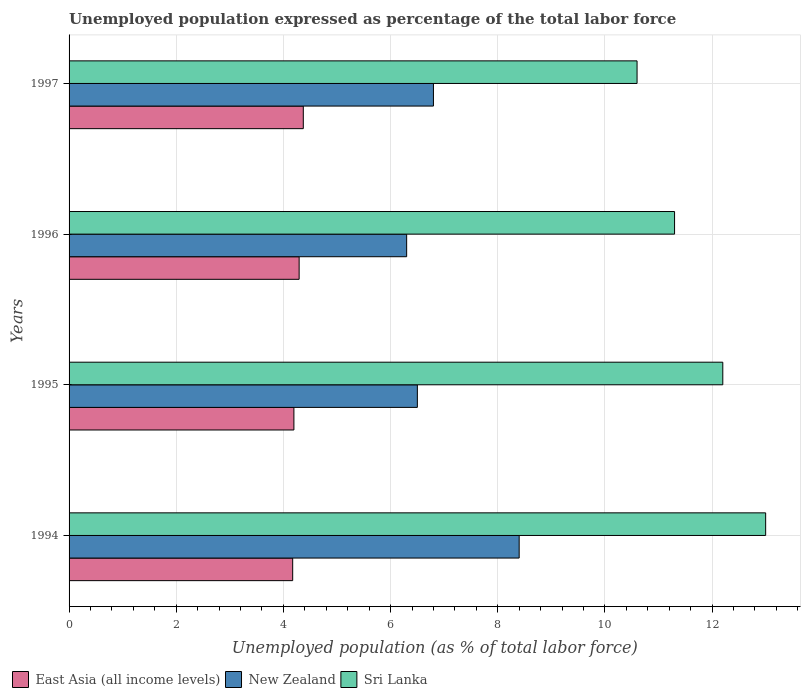How many bars are there on the 1st tick from the top?
Provide a short and direct response. 3. How many bars are there on the 4th tick from the bottom?
Your answer should be compact. 3. What is the label of the 4th group of bars from the top?
Provide a short and direct response. 1994. In how many cases, is the number of bars for a given year not equal to the number of legend labels?
Provide a short and direct response. 0. What is the unemployment in in East Asia (all income levels) in 1997?
Give a very brief answer. 4.37. Across all years, what is the maximum unemployment in in New Zealand?
Your answer should be compact. 8.4. Across all years, what is the minimum unemployment in in Sri Lanka?
Offer a very short reply. 10.6. In which year was the unemployment in in Sri Lanka maximum?
Provide a succinct answer. 1994. In which year was the unemployment in in Sri Lanka minimum?
Keep it short and to the point. 1997. What is the total unemployment in in Sri Lanka in the graph?
Make the answer very short. 47.1. What is the difference between the unemployment in in Sri Lanka in 1995 and that in 1997?
Offer a very short reply. 1.6. What is the difference between the unemployment in in New Zealand in 1994 and the unemployment in in Sri Lanka in 1996?
Give a very brief answer. -2.9. What is the average unemployment in in New Zealand per year?
Ensure brevity in your answer.  7. In the year 1996, what is the difference between the unemployment in in Sri Lanka and unemployment in in New Zealand?
Your answer should be very brief. 5. What is the ratio of the unemployment in in East Asia (all income levels) in 1995 to that in 1996?
Provide a short and direct response. 0.98. What is the difference between the highest and the second highest unemployment in in East Asia (all income levels)?
Offer a very short reply. 0.08. What is the difference between the highest and the lowest unemployment in in New Zealand?
Your answer should be compact. 2.1. Is the sum of the unemployment in in Sri Lanka in 1994 and 1996 greater than the maximum unemployment in in New Zealand across all years?
Make the answer very short. Yes. What does the 1st bar from the top in 1996 represents?
Offer a very short reply. Sri Lanka. What does the 1st bar from the bottom in 1996 represents?
Provide a succinct answer. East Asia (all income levels). Are all the bars in the graph horizontal?
Offer a very short reply. Yes. How many years are there in the graph?
Your answer should be compact. 4. What is the difference between two consecutive major ticks on the X-axis?
Provide a short and direct response. 2. Are the values on the major ticks of X-axis written in scientific E-notation?
Make the answer very short. No. How are the legend labels stacked?
Offer a terse response. Horizontal. What is the title of the graph?
Make the answer very short. Unemployed population expressed as percentage of the total labor force. Does "Bolivia" appear as one of the legend labels in the graph?
Offer a very short reply. No. What is the label or title of the X-axis?
Your answer should be very brief. Unemployed population (as % of total labor force). What is the label or title of the Y-axis?
Offer a terse response. Years. What is the Unemployed population (as % of total labor force) of East Asia (all income levels) in 1994?
Keep it short and to the point. 4.17. What is the Unemployed population (as % of total labor force) of New Zealand in 1994?
Provide a succinct answer. 8.4. What is the Unemployed population (as % of total labor force) of Sri Lanka in 1994?
Your answer should be very brief. 13. What is the Unemployed population (as % of total labor force) in East Asia (all income levels) in 1995?
Provide a short and direct response. 4.2. What is the Unemployed population (as % of total labor force) in New Zealand in 1995?
Make the answer very short. 6.5. What is the Unemployed population (as % of total labor force) in Sri Lanka in 1995?
Provide a short and direct response. 12.2. What is the Unemployed population (as % of total labor force) in East Asia (all income levels) in 1996?
Provide a short and direct response. 4.29. What is the Unemployed population (as % of total labor force) in New Zealand in 1996?
Your answer should be very brief. 6.3. What is the Unemployed population (as % of total labor force) in Sri Lanka in 1996?
Your answer should be compact. 11.3. What is the Unemployed population (as % of total labor force) of East Asia (all income levels) in 1997?
Your answer should be compact. 4.37. What is the Unemployed population (as % of total labor force) of New Zealand in 1997?
Make the answer very short. 6.8. What is the Unemployed population (as % of total labor force) in Sri Lanka in 1997?
Your response must be concise. 10.6. Across all years, what is the maximum Unemployed population (as % of total labor force) of East Asia (all income levels)?
Offer a very short reply. 4.37. Across all years, what is the maximum Unemployed population (as % of total labor force) in New Zealand?
Your answer should be very brief. 8.4. Across all years, what is the minimum Unemployed population (as % of total labor force) of East Asia (all income levels)?
Make the answer very short. 4.17. Across all years, what is the minimum Unemployed population (as % of total labor force) of New Zealand?
Offer a terse response. 6.3. Across all years, what is the minimum Unemployed population (as % of total labor force) in Sri Lanka?
Offer a very short reply. 10.6. What is the total Unemployed population (as % of total labor force) in East Asia (all income levels) in the graph?
Your response must be concise. 17.03. What is the total Unemployed population (as % of total labor force) in Sri Lanka in the graph?
Provide a short and direct response. 47.1. What is the difference between the Unemployed population (as % of total labor force) of East Asia (all income levels) in 1994 and that in 1995?
Offer a terse response. -0.02. What is the difference between the Unemployed population (as % of total labor force) of Sri Lanka in 1994 and that in 1995?
Give a very brief answer. 0.8. What is the difference between the Unemployed population (as % of total labor force) of East Asia (all income levels) in 1994 and that in 1996?
Offer a terse response. -0.12. What is the difference between the Unemployed population (as % of total labor force) in New Zealand in 1994 and that in 1996?
Ensure brevity in your answer.  2.1. What is the difference between the Unemployed population (as % of total labor force) of Sri Lanka in 1994 and that in 1996?
Provide a succinct answer. 1.7. What is the difference between the Unemployed population (as % of total labor force) in East Asia (all income levels) in 1994 and that in 1997?
Make the answer very short. -0.2. What is the difference between the Unemployed population (as % of total labor force) of Sri Lanka in 1994 and that in 1997?
Keep it short and to the point. 2.4. What is the difference between the Unemployed population (as % of total labor force) of East Asia (all income levels) in 1995 and that in 1996?
Provide a short and direct response. -0.1. What is the difference between the Unemployed population (as % of total labor force) of Sri Lanka in 1995 and that in 1996?
Your response must be concise. 0.9. What is the difference between the Unemployed population (as % of total labor force) of East Asia (all income levels) in 1995 and that in 1997?
Offer a terse response. -0.18. What is the difference between the Unemployed population (as % of total labor force) of East Asia (all income levels) in 1996 and that in 1997?
Your response must be concise. -0.08. What is the difference between the Unemployed population (as % of total labor force) in New Zealand in 1996 and that in 1997?
Provide a short and direct response. -0.5. What is the difference between the Unemployed population (as % of total labor force) of Sri Lanka in 1996 and that in 1997?
Your response must be concise. 0.7. What is the difference between the Unemployed population (as % of total labor force) in East Asia (all income levels) in 1994 and the Unemployed population (as % of total labor force) in New Zealand in 1995?
Offer a very short reply. -2.33. What is the difference between the Unemployed population (as % of total labor force) of East Asia (all income levels) in 1994 and the Unemployed population (as % of total labor force) of Sri Lanka in 1995?
Make the answer very short. -8.03. What is the difference between the Unemployed population (as % of total labor force) in East Asia (all income levels) in 1994 and the Unemployed population (as % of total labor force) in New Zealand in 1996?
Provide a succinct answer. -2.13. What is the difference between the Unemployed population (as % of total labor force) of East Asia (all income levels) in 1994 and the Unemployed population (as % of total labor force) of Sri Lanka in 1996?
Your answer should be very brief. -7.13. What is the difference between the Unemployed population (as % of total labor force) of East Asia (all income levels) in 1994 and the Unemployed population (as % of total labor force) of New Zealand in 1997?
Keep it short and to the point. -2.63. What is the difference between the Unemployed population (as % of total labor force) in East Asia (all income levels) in 1994 and the Unemployed population (as % of total labor force) in Sri Lanka in 1997?
Offer a very short reply. -6.43. What is the difference between the Unemployed population (as % of total labor force) in East Asia (all income levels) in 1995 and the Unemployed population (as % of total labor force) in New Zealand in 1996?
Make the answer very short. -2.1. What is the difference between the Unemployed population (as % of total labor force) in East Asia (all income levels) in 1995 and the Unemployed population (as % of total labor force) in Sri Lanka in 1996?
Offer a terse response. -7.1. What is the difference between the Unemployed population (as % of total labor force) of New Zealand in 1995 and the Unemployed population (as % of total labor force) of Sri Lanka in 1996?
Your answer should be compact. -4.8. What is the difference between the Unemployed population (as % of total labor force) in East Asia (all income levels) in 1995 and the Unemployed population (as % of total labor force) in New Zealand in 1997?
Your response must be concise. -2.6. What is the difference between the Unemployed population (as % of total labor force) in East Asia (all income levels) in 1995 and the Unemployed population (as % of total labor force) in Sri Lanka in 1997?
Provide a succinct answer. -6.4. What is the difference between the Unemployed population (as % of total labor force) in New Zealand in 1995 and the Unemployed population (as % of total labor force) in Sri Lanka in 1997?
Keep it short and to the point. -4.1. What is the difference between the Unemployed population (as % of total labor force) of East Asia (all income levels) in 1996 and the Unemployed population (as % of total labor force) of New Zealand in 1997?
Make the answer very short. -2.51. What is the difference between the Unemployed population (as % of total labor force) of East Asia (all income levels) in 1996 and the Unemployed population (as % of total labor force) of Sri Lanka in 1997?
Offer a terse response. -6.31. What is the difference between the Unemployed population (as % of total labor force) of New Zealand in 1996 and the Unemployed population (as % of total labor force) of Sri Lanka in 1997?
Keep it short and to the point. -4.3. What is the average Unemployed population (as % of total labor force) in East Asia (all income levels) per year?
Offer a terse response. 4.26. What is the average Unemployed population (as % of total labor force) in New Zealand per year?
Provide a succinct answer. 7. What is the average Unemployed population (as % of total labor force) in Sri Lanka per year?
Provide a short and direct response. 11.78. In the year 1994, what is the difference between the Unemployed population (as % of total labor force) of East Asia (all income levels) and Unemployed population (as % of total labor force) of New Zealand?
Provide a succinct answer. -4.23. In the year 1994, what is the difference between the Unemployed population (as % of total labor force) in East Asia (all income levels) and Unemployed population (as % of total labor force) in Sri Lanka?
Give a very brief answer. -8.83. In the year 1995, what is the difference between the Unemployed population (as % of total labor force) in East Asia (all income levels) and Unemployed population (as % of total labor force) in New Zealand?
Offer a very short reply. -2.3. In the year 1995, what is the difference between the Unemployed population (as % of total labor force) in East Asia (all income levels) and Unemployed population (as % of total labor force) in Sri Lanka?
Your answer should be very brief. -8. In the year 1996, what is the difference between the Unemployed population (as % of total labor force) in East Asia (all income levels) and Unemployed population (as % of total labor force) in New Zealand?
Your response must be concise. -2.01. In the year 1996, what is the difference between the Unemployed population (as % of total labor force) of East Asia (all income levels) and Unemployed population (as % of total labor force) of Sri Lanka?
Your answer should be compact. -7.01. In the year 1997, what is the difference between the Unemployed population (as % of total labor force) of East Asia (all income levels) and Unemployed population (as % of total labor force) of New Zealand?
Your answer should be compact. -2.43. In the year 1997, what is the difference between the Unemployed population (as % of total labor force) of East Asia (all income levels) and Unemployed population (as % of total labor force) of Sri Lanka?
Your answer should be compact. -6.23. In the year 1997, what is the difference between the Unemployed population (as % of total labor force) of New Zealand and Unemployed population (as % of total labor force) of Sri Lanka?
Your answer should be compact. -3.8. What is the ratio of the Unemployed population (as % of total labor force) in East Asia (all income levels) in 1994 to that in 1995?
Ensure brevity in your answer.  0.99. What is the ratio of the Unemployed population (as % of total labor force) in New Zealand in 1994 to that in 1995?
Provide a short and direct response. 1.29. What is the ratio of the Unemployed population (as % of total labor force) in Sri Lanka in 1994 to that in 1995?
Provide a succinct answer. 1.07. What is the ratio of the Unemployed population (as % of total labor force) in East Asia (all income levels) in 1994 to that in 1996?
Ensure brevity in your answer.  0.97. What is the ratio of the Unemployed population (as % of total labor force) in New Zealand in 1994 to that in 1996?
Your answer should be compact. 1.33. What is the ratio of the Unemployed population (as % of total labor force) of Sri Lanka in 1994 to that in 1996?
Ensure brevity in your answer.  1.15. What is the ratio of the Unemployed population (as % of total labor force) in East Asia (all income levels) in 1994 to that in 1997?
Your response must be concise. 0.95. What is the ratio of the Unemployed population (as % of total labor force) in New Zealand in 1994 to that in 1997?
Ensure brevity in your answer.  1.24. What is the ratio of the Unemployed population (as % of total labor force) of Sri Lanka in 1994 to that in 1997?
Make the answer very short. 1.23. What is the ratio of the Unemployed population (as % of total labor force) of East Asia (all income levels) in 1995 to that in 1996?
Your answer should be very brief. 0.98. What is the ratio of the Unemployed population (as % of total labor force) of New Zealand in 1995 to that in 1996?
Give a very brief answer. 1.03. What is the ratio of the Unemployed population (as % of total labor force) in Sri Lanka in 1995 to that in 1996?
Your answer should be compact. 1.08. What is the ratio of the Unemployed population (as % of total labor force) in East Asia (all income levels) in 1995 to that in 1997?
Provide a short and direct response. 0.96. What is the ratio of the Unemployed population (as % of total labor force) of New Zealand in 1995 to that in 1997?
Your answer should be compact. 0.96. What is the ratio of the Unemployed population (as % of total labor force) in Sri Lanka in 1995 to that in 1997?
Give a very brief answer. 1.15. What is the ratio of the Unemployed population (as % of total labor force) of East Asia (all income levels) in 1996 to that in 1997?
Give a very brief answer. 0.98. What is the ratio of the Unemployed population (as % of total labor force) in New Zealand in 1996 to that in 1997?
Ensure brevity in your answer.  0.93. What is the ratio of the Unemployed population (as % of total labor force) in Sri Lanka in 1996 to that in 1997?
Your answer should be very brief. 1.07. What is the difference between the highest and the second highest Unemployed population (as % of total labor force) of East Asia (all income levels)?
Provide a short and direct response. 0.08. What is the difference between the highest and the lowest Unemployed population (as % of total labor force) of East Asia (all income levels)?
Give a very brief answer. 0.2. What is the difference between the highest and the lowest Unemployed population (as % of total labor force) of Sri Lanka?
Your response must be concise. 2.4. 